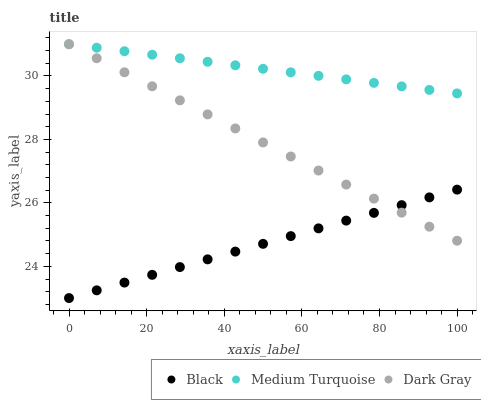Does Black have the minimum area under the curve?
Answer yes or no. Yes. Does Medium Turquoise have the maximum area under the curve?
Answer yes or no. Yes. Does Medium Turquoise have the minimum area under the curve?
Answer yes or no. No. Does Black have the maximum area under the curve?
Answer yes or no. No. Is Medium Turquoise the smoothest?
Answer yes or no. Yes. Is Dark Gray the roughest?
Answer yes or no. Yes. Is Black the smoothest?
Answer yes or no. No. Is Black the roughest?
Answer yes or no. No. Does Black have the lowest value?
Answer yes or no. Yes. Does Medium Turquoise have the lowest value?
Answer yes or no. No. Does Medium Turquoise have the highest value?
Answer yes or no. Yes. Does Black have the highest value?
Answer yes or no. No. Is Black less than Medium Turquoise?
Answer yes or no. Yes. Is Medium Turquoise greater than Black?
Answer yes or no. Yes. Does Black intersect Dark Gray?
Answer yes or no. Yes. Is Black less than Dark Gray?
Answer yes or no. No. Is Black greater than Dark Gray?
Answer yes or no. No. Does Black intersect Medium Turquoise?
Answer yes or no. No. 